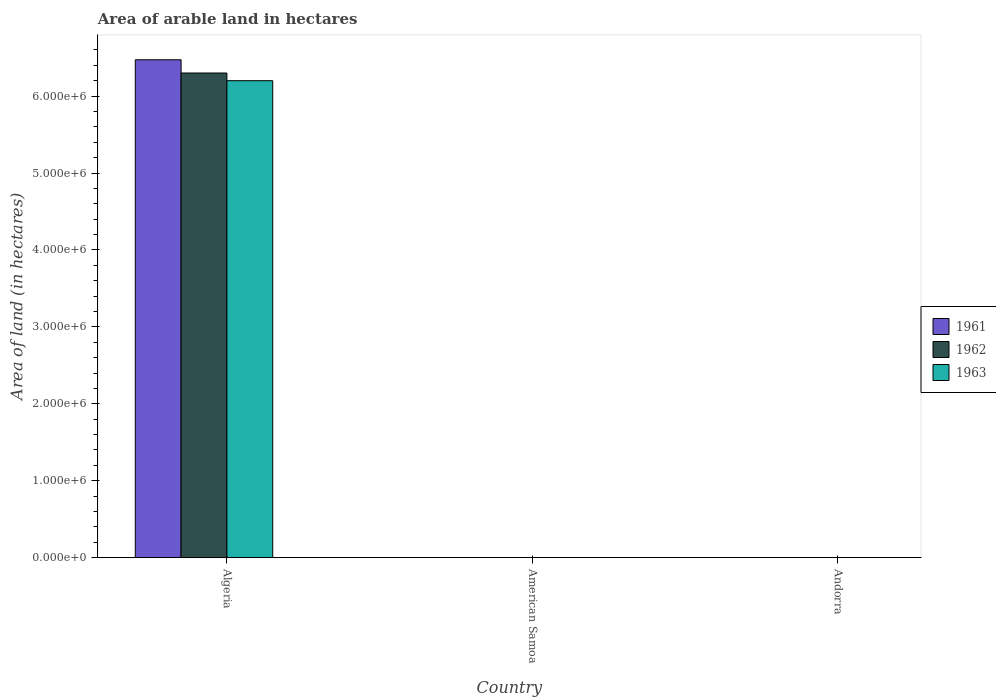How many groups of bars are there?
Offer a terse response. 3. Are the number of bars per tick equal to the number of legend labels?
Offer a very short reply. Yes. Are the number of bars on each tick of the X-axis equal?
Keep it short and to the point. Yes. How many bars are there on the 1st tick from the right?
Your response must be concise. 3. What is the label of the 1st group of bars from the left?
Ensure brevity in your answer.  Algeria. What is the total arable land in 1961 in Algeria?
Provide a succinct answer. 6.47e+06. Across all countries, what is the maximum total arable land in 1963?
Offer a terse response. 6.20e+06. In which country was the total arable land in 1962 maximum?
Provide a short and direct response. Algeria. In which country was the total arable land in 1963 minimum?
Give a very brief answer. American Samoa. What is the total total arable land in 1961 in the graph?
Your response must be concise. 6.47e+06. What is the difference between the total arable land in 1961 in Algeria and that in Andorra?
Offer a terse response. 6.47e+06. What is the difference between the total arable land in 1961 in Algeria and the total arable land in 1963 in Andorra?
Give a very brief answer. 6.47e+06. What is the average total arable land in 1963 per country?
Give a very brief answer. 2.07e+06. What is the ratio of the total arable land in 1961 in American Samoa to that in Andorra?
Ensure brevity in your answer.  1. Is the total arable land in 1963 in American Samoa less than that in Andorra?
Give a very brief answer. No. Is the difference between the total arable land in 1962 in Algeria and Andorra greater than the difference between the total arable land in 1963 in Algeria and Andorra?
Ensure brevity in your answer.  Yes. What is the difference between the highest and the second highest total arable land in 1961?
Your response must be concise. 6.47e+06. What is the difference between the highest and the lowest total arable land in 1962?
Provide a succinct answer. 6.30e+06. Is the sum of the total arable land in 1963 in American Samoa and Andorra greater than the maximum total arable land in 1962 across all countries?
Ensure brevity in your answer.  No. What does the 3rd bar from the right in Algeria represents?
Provide a short and direct response. 1961. Are the values on the major ticks of Y-axis written in scientific E-notation?
Keep it short and to the point. Yes. Where does the legend appear in the graph?
Offer a very short reply. Center right. How many legend labels are there?
Offer a terse response. 3. How are the legend labels stacked?
Your answer should be compact. Vertical. What is the title of the graph?
Ensure brevity in your answer.  Area of arable land in hectares. What is the label or title of the X-axis?
Your response must be concise. Country. What is the label or title of the Y-axis?
Ensure brevity in your answer.  Area of land (in hectares). What is the Area of land (in hectares) of 1961 in Algeria?
Your answer should be compact. 6.47e+06. What is the Area of land (in hectares) of 1962 in Algeria?
Your answer should be very brief. 6.30e+06. What is the Area of land (in hectares) of 1963 in Algeria?
Your answer should be very brief. 6.20e+06. What is the Area of land (in hectares) in 1961 in American Samoa?
Make the answer very short. 1000. What is the Area of land (in hectares) in 1962 in American Samoa?
Make the answer very short. 1000. What is the Area of land (in hectares) of 1961 in Andorra?
Ensure brevity in your answer.  1000. What is the Area of land (in hectares) in 1962 in Andorra?
Give a very brief answer. 1000. What is the Area of land (in hectares) in 1963 in Andorra?
Offer a very short reply. 1000. Across all countries, what is the maximum Area of land (in hectares) in 1961?
Your answer should be compact. 6.47e+06. Across all countries, what is the maximum Area of land (in hectares) in 1962?
Ensure brevity in your answer.  6.30e+06. Across all countries, what is the maximum Area of land (in hectares) in 1963?
Make the answer very short. 6.20e+06. Across all countries, what is the minimum Area of land (in hectares) of 1961?
Provide a succinct answer. 1000. Across all countries, what is the minimum Area of land (in hectares) of 1962?
Make the answer very short. 1000. What is the total Area of land (in hectares) of 1961 in the graph?
Make the answer very short. 6.47e+06. What is the total Area of land (in hectares) of 1962 in the graph?
Keep it short and to the point. 6.30e+06. What is the total Area of land (in hectares) of 1963 in the graph?
Give a very brief answer. 6.20e+06. What is the difference between the Area of land (in hectares) of 1961 in Algeria and that in American Samoa?
Make the answer very short. 6.47e+06. What is the difference between the Area of land (in hectares) of 1962 in Algeria and that in American Samoa?
Provide a short and direct response. 6.30e+06. What is the difference between the Area of land (in hectares) of 1963 in Algeria and that in American Samoa?
Provide a succinct answer. 6.20e+06. What is the difference between the Area of land (in hectares) of 1961 in Algeria and that in Andorra?
Give a very brief answer. 6.47e+06. What is the difference between the Area of land (in hectares) of 1962 in Algeria and that in Andorra?
Ensure brevity in your answer.  6.30e+06. What is the difference between the Area of land (in hectares) of 1963 in Algeria and that in Andorra?
Your answer should be very brief. 6.20e+06. What is the difference between the Area of land (in hectares) of 1963 in American Samoa and that in Andorra?
Make the answer very short. 0. What is the difference between the Area of land (in hectares) of 1961 in Algeria and the Area of land (in hectares) of 1962 in American Samoa?
Offer a terse response. 6.47e+06. What is the difference between the Area of land (in hectares) of 1961 in Algeria and the Area of land (in hectares) of 1963 in American Samoa?
Provide a succinct answer. 6.47e+06. What is the difference between the Area of land (in hectares) in 1962 in Algeria and the Area of land (in hectares) in 1963 in American Samoa?
Your response must be concise. 6.30e+06. What is the difference between the Area of land (in hectares) in 1961 in Algeria and the Area of land (in hectares) in 1962 in Andorra?
Offer a terse response. 6.47e+06. What is the difference between the Area of land (in hectares) of 1961 in Algeria and the Area of land (in hectares) of 1963 in Andorra?
Provide a succinct answer. 6.47e+06. What is the difference between the Area of land (in hectares) in 1962 in Algeria and the Area of land (in hectares) in 1963 in Andorra?
Offer a very short reply. 6.30e+06. What is the difference between the Area of land (in hectares) in 1961 in American Samoa and the Area of land (in hectares) in 1963 in Andorra?
Keep it short and to the point. 0. What is the average Area of land (in hectares) in 1961 per country?
Provide a short and direct response. 2.16e+06. What is the average Area of land (in hectares) in 1962 per country?
Your answer should be compact. 2.10e+06. What is the average Area of land (in hectares) of 1963 per country?
Ensure brevity in your answer.  2.07e+06. What is the difference between the Area of land (in hectares) in 1961 and Area of land (in hectares) in 1962 in Algeria?
Your answer should be very brief. 1.72e+05. What is the difference between the Area of land (in hectares) in 1961 and Area of land (in hectares) in 1963 in Algeria?
Your answer should be compact. 2.72e+05. What is the difference between the Area of land (in hectares) in 1962 and Area of land (in hectares) in 1963 in Algeria?
Offer a terse response. 1.00e+05. What is the difference between the Area of land (in hectares) in 1961 and Area of land (in hectares) in 1962 in American Samoa?
Ensure brevity in your answer.  0. What is the difference between the Area of land (in hectares) in 1961 and Area of land (in hectares) in 1963 in American Samoa?
Keep it short and to the point. 0. What is the difference between the Area of land (in hectares) in 1961 and Area of land (in hectares) in 1962 in Andorra?
Make the answer very short. 0. What is the ratio of the Area of land (in hectares) of 1961 in Algeria to that in American Samoa?
Make the answer very short. 6472. What is the ratio of the Area of land (in hectares) in 1962 in Algeria to that in American Samoa?
Keep it short and to the point. 6300. What is the ratio of the Area of land (in hectares) of 1963 in Algeria to that in American Samoa?
Provide a short and direct response. 6200. What is the ratio of the Area of land (in hectares) in 1961 in Algeria to that in Andorra?
Your answer should be very brief. 6472. What is the ratio of the Area of land (in hectares) in 1962 in Algeria to that in Andorra?
Keep it short and to the point. 6300. What is the ratio of the Area of land (in hectares) in 1963 in Algeria to that in Andorra?
Keep it short and to the point. 6200. What is the ratio of the Area of land (in hectares) of 1961 in American Samoa to that in Andorra?
Offer a terse response. 1. What is the difference between the highest and the second highest Area of land (in hectares) of 1961?
Your response must be concise. 6.47e+06. What is the difference between the highest and the second highest Area of land (in hectares) of 1962?
Ensure brevity in your answer.  6.30e+06. What is the difference between the highest and the second highest Area of land (in hectares) in 1963?
Provide a succinct answer. 6.20e+06. What is the difference between the highest and the lowest Area of land (in hectares) of 1961?
Keep it short and to the point. 6.47e+06. What is the difference between the highest and the lowest Area of land (in hectares) in 1962?
Offer a terse response. 6.30e+06. What is the difference between the highest and the lowest Area of land (in hectares) of 1963?
Offer a terse response. 6.20e+06. 